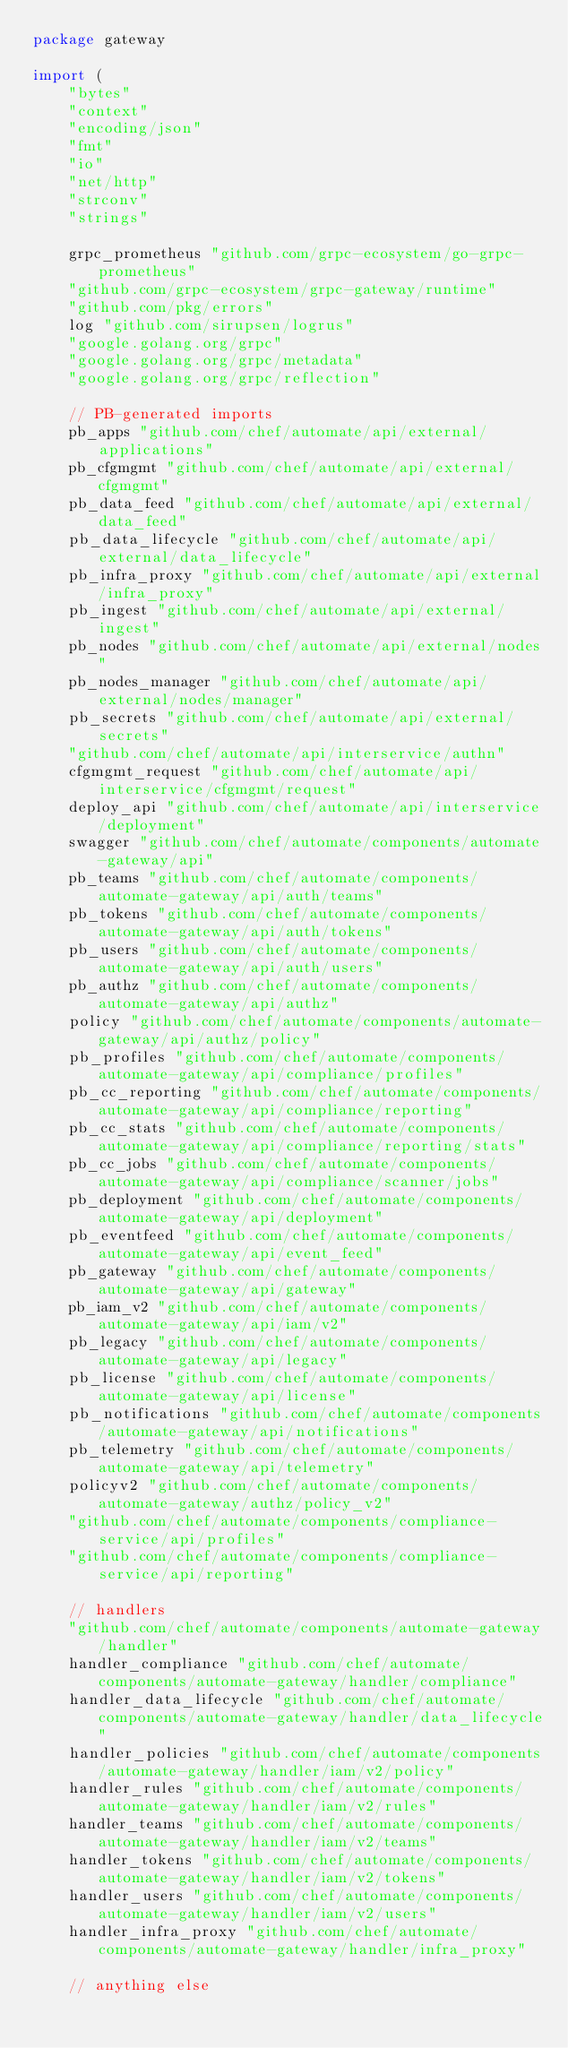Convert code to text. <code><loc_0><loc_0><loc_500><loc_500><_Go_>package gateway

import (
	"bytes"
	"context"
	"encoding/json"
	"fmt"
	"io"
	"net/http"
	"strconv"
	"strings"

	grpc_prometheus "github.com/grpc-ecosystem/go-grpc-prometheus"
	"github.com/grpc-ecosystem/grpc-gateway/runtime"
	"github.com/pkg/errors"
	log "github.com/sirupsen/logrus"
	"google.golang.org/grpc"
	"google.golang.org/grpc/metadata"
	"google.golang.org/grpc/reflection"

	// PB-generated imports
	pb_apps "github.com/chef/automate/api/external/applications"
	pb_cfgmgmt "github.com/chef/automate/api/external/cfgmgmt"
	pb_data_feed "github.com/chef/automate/api/external/data_feed"
	pb_data_lifecycle "github.com/chef/automate/api/external/data_lifecycle"
	pb_infra_proxy "github.com/chef/automate/api/external/infra_proxy"
	pb_ingest "github.com/chef/automate/api/external/ingest"
	pb_nodes "github.com/chef/automate/api/external/nodes"
	pb_nodes_manager "github.com/chef/automate/api/external/nodes/manager"
	pb_secrets "github.com/chef/automate/api/external/secrets"
	"github.com/chef/automate/api/interservice/authn"
	cfgmgmt_request "github.com/chef/automate/api/interservice/cfgmgmt/request"
	deploy_api "github.com/chef/automate/api/interservice/deployment"
	swagger "github.com/chef/automate/components/automate-gateway/api"
	pb_teams "github.com/chef/automate/components/automate-gateway/api/auth/teams"
	pb_tokens "github.com/chef/automate/components/automate-gateway/api/auth/tokens"
	pb_users "github.com/chef/automate/components/automate-gateway/api/auth/users"
	pb_authz "github.com/chef/automate/components/automate-gateway/api/authz"
	policy "github.com/chef/automate/components/automate-gateway/api/authz/policy"
	pb_profiles "github.com/chef/automate/components/automate-gateway/api/compliance/profiles"
	pb_cc_reporting "github.com/chef/automate/components/automate-gateway/api/compliance/reporting"
	pb_cc_stats "github.com/chef/automate/components/automate-gateway/api/compliance/reporting/stats"
	pb_cc_jobs "github.com/chef/automate/components/automate-gateway/api/compliance/scanner/jobs"
	pb_deployment "github.com/chef/automate/components/automate-gateway/api/deployment"
	pb_eventfeed "github.com/chef/automate/components/automate-gateway/api/event_feed"
	pb_gateway "github.com/chef/automate/components/automate-gateway/api/gateway"
	pb_iam_v2 "github.com/chef/automate/components/automate-gateway/api/iam/v2"
	pb_legacy "github.com/chef/automate/components/automate-gateway/api/legacy"
	pb_license "github.com/chef/automate/components/automate-gateway/api/license"
	pb_notifications "github.com/chef/automate/components/automate-gateway/api/notifications"
	pb_telemetry "github.com/chef/automate/components/automate-gateway/api/telemetry"
	policyv2 "github.com/chef/automate/components/automate-gateway/authz/policy_v2"
	"github.com/chef/automate/components/compliance-service/api/profiles"
	"github.com/chef/automate/components/compliance-service/api/reporting"

	// handlers
	"github.com/chef/automate/components/automate-gateway/handler"
	handler_compliance "github.com/chef/automate/components/automate-gateway/handler/compliance"
	handler_data_lifecycle "github.com/chef/automate/components/automate-gateway/handler/data_lifecycle"
	handler_policies "github.com/chef/automate/components/automate-gateway/handler/iam/v2/policy"
	handler_rules "github.com/chef/automate/components/automate-gateway/handler/iam/v2/rules"
	handler_teams "github.com/chef/automate/components/automate-gateway/handler/iam/v2/teams"
	handler_tokens "github.com/chef/automate/components/automate-gateway/handler/iam/v2/tokens"
	handler_users "github.com/chef/automate/components/automate-gateway/handler/iam/v2/users"
	handler_infra_proxy "github.com/chef/automate/components/automate-gateway/handler/infra_proxy"

	// anything else</code> 